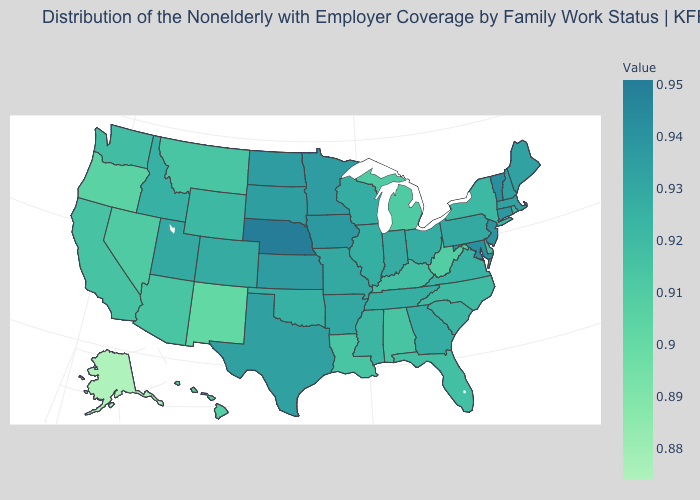Is the legend a continuous bar?
Keep it brief. Yes. Among the states that border Utah , which have the lowest value?
Answer briefly. New Mexico. Among the states that border Montana , does Wyoming have the highest value?
Write a very short answer. No. Does Nebraska have the highest value in the MidWest?
Concise answer only. Yes. Which states hav the highest value in the West?
Give a very brief answer. Utah. 